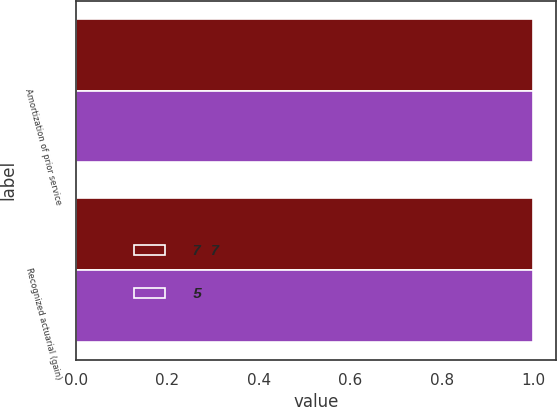Convert chart. <chart><loc_0><loc_0><loc_500><loc_500><stacked_bar_chart><ecel><fcel>Amortization of prior service<fcel>Recognized actuarial (gain)<nl><fcel>7 7<fcel>1<fcel>1<nl><fcel>5<fcel>1<fcel>1<nl></chart> 